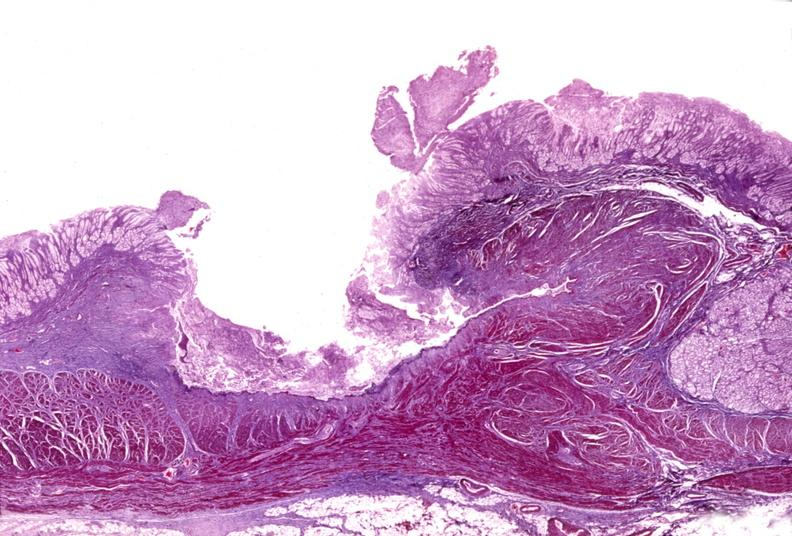s gastrointestinal present?
Answer the question using a single word or phrase. Yes 